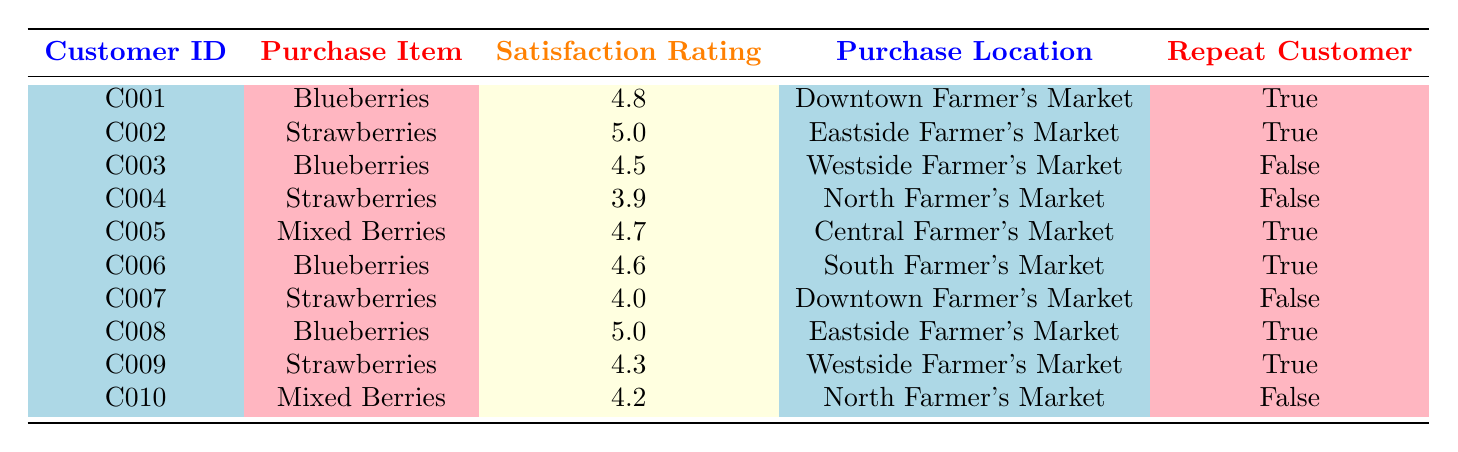What was the highest satisfaction rating given, and for which item? The highest satisfaction rating in the table is 5.0, given for "Strawberries" by customer C002 and "Blueberries" by customer C008.
Answer: 5.0 for Strawberries (C002) How many customers gave a satisfaction rating of 4.5 or lower? There are three customers with ratings of 4.5 or lower: C003 (4.5), C004 (3.9), and C010 (4.2), leading to a total of three customers.
Answer: 3 customers Which purchase location had the highest satisfaction rating overall? To find the location with the highest satisfaction rating, we look at all ratings: Downtown (4.8, 4.0), Eastside (5.0, 4.3), Westside (4.5, 4.3), North (3.9, 4.2), and Central (4.7). The highest is 5.0 from Eastside Farmer's Market.
Answer: Eastside Farmer's Market Is there any customer who purchased mixed berries and returned for another purchase? Customer C005 purchased mixed berries and is marked as a repeat customer, confirming that there is at least one returning customer for mixed berries.
Answer: Yes What is the average satisfaction rating for blueberries sold at the farmer's markets? The ratings for blueberries are 4.8, 4.5, 4.6, and 5.0. We sum them: 4.8 + 4.5 + 4.6 + 5.0 = 19.9. There are 4 ratings, so we calculate 19.9 / 4 = 4.975.
Answer: 4.975 